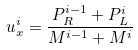<formula> <loc_0><loc_0><loc_500><loc_500>u _ { x } ^ { i } = \frac { P _ { R } ^ { i - 1 } + P _ { L } ^ { i } } { M ^ { i - 1 } + M ^ { i } }</formula> 